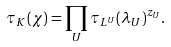Convert formula to latex. <formula><loc_0><loc_0><loc_500><loc_500>\tau _ { K } ( \chi ) = \prod _ { U } \tau _ { L ^ { U } } ( \lambda _ { U } ) ^ { z _ { U } } .</formula> 